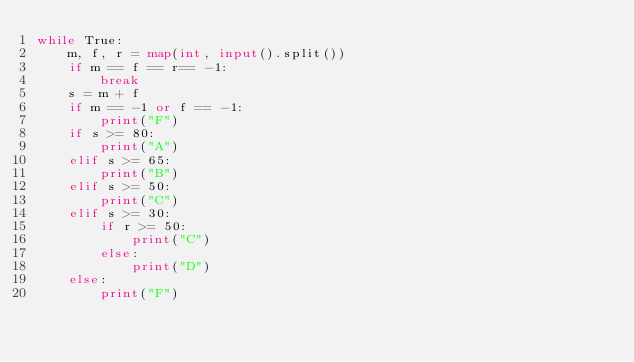<code> <loc_0><loc_0><loc_500><loc_500><_Python_>while True:
    m, f, r = map(int, input().split())
    if m == f == r== -1:
        break
    s = m + f
    if m == -1 or f == -1:
        print("F")
    if s >= 80:
        print("A")
    elif s >= 65:
        print("B")
    elif s >= 50:
        print("C")
    elif s >= 30:
        if r >= 50:
            print("C")
        else:
            print("D")
    else:
        print("F")
    


</code> 